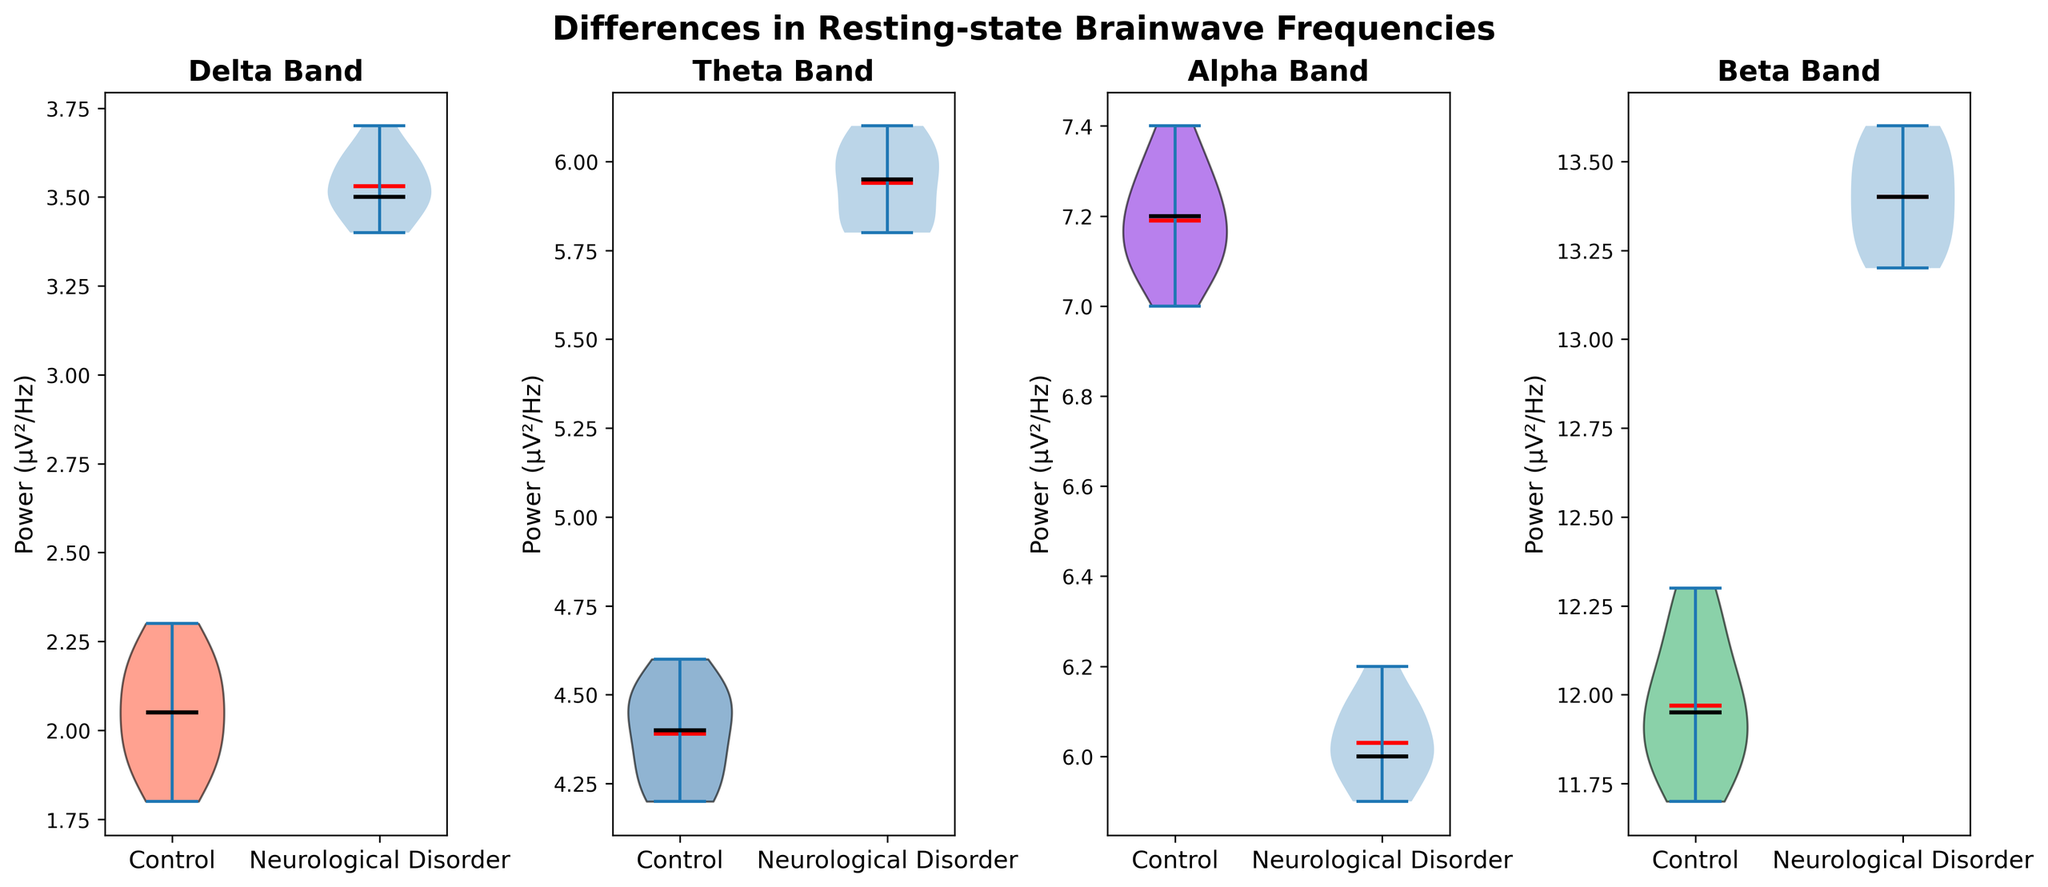Which group has higher median delta brainwave power? Observe the central line (black) of the delta band violins for both groups. The neurological disorder group has a higher median line.
Answer: Neurological disorder What is the mean theta brainwave power for the control group? Look for the red line inside the control group violin for the theta band. This line marks the mean value for the control group.
Answer: Approximately 4.4 How does the spread of alpha brainwave power compare between the control and neurological disorder groups? Compare the width of the violin plots for the alpha band. The control group has a wider spread, indicating more variability.
Answer: Control has more variability Which group shows a higher mean in beta brainwave power? Identify the red lines within the beta band violins. The neurological disorder group has a higher mean line.
Answer: Neurological disorder Is the median beta brainwave power greater for the control group or the neurological disorder group? Compare the central lines (black) of the beta band violins between the two groups. The neurological disorder group has a higher median line.
Answer: Neurological disorder Between delta and alpha bands, which one has a higher median value for the neurological disorder group? Observe the central lines (black) of the delta and alpha band violins within the neurological disorder group. Delta has a higher median.
Answer: Delta How does the mean delta brainwave power for neurological disorder compare to the mean delta brainwave power for the control group? Compare the red lines for the delta band between both groups. The neurological disorder group has a higher mean value.
Answer: Neurological disorder is higher Does the control group show more spread in theta or alpha brainwave power? Compare the widths of the theta and alpha violins for the control group. Alpha shows more spread.
Answer: Alpha has more spread Which band shows the least difference in medians between the two groups? Compare the central lines (black) of the violin plots across all bands. The beta band shows the least difference.
Answer: Beta Are the medians of the theta brainwave power higher for the control group or the neurological disorder group? Compare the central lines (black) of the theta band violins. The neurological disorder group shows higher medians.
Answer: Neurological disorder 